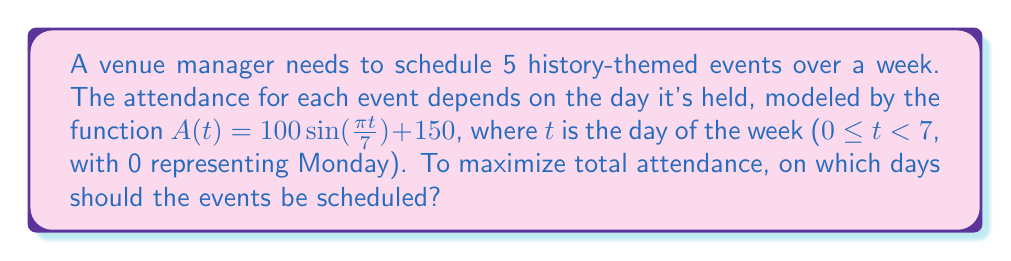What is the answer to this math problem? 1. The attendance function $A(t) = 100 \sin(\frac{\pi t}{7}) + 150$ represents a sinusoidal curve with a period of 7 days.

2. To maximize total attendance, we need to find the 5 highest points on this curve within the domain 0 ≤ t < 7.

3. The maximum of a sine function occurs at $\frac{\pi}{2} + 2\pi n$, where n is an integer. In our case:

   $$\frac{\pi t}{7} = \frac{\pi}{2}$$
   $$t = \frac{7}{2} = 3.5$$

4. This maximum occurs on Thursday afternoon (day 3.5). The next highest points will be equally spaced on either side of this peak.

5. To find these points, we can use the following formula:
   $$t_k = 3.5 + k, \text{ where } k = \{-2, -1, 0, 1, 2\}$$

6. This gives us:
   $t_1 = 1.5$ (Tuesday afternoon)
   $t_2 = 2.5$ (Wednesday afternoon)
   $t_3 = 3.5$ (Thursday afternoon)
   $t_4 = 4.5$ (Friday afternoon)
   $t_5 = 5.5$ (Saturday afternoon)

7. Rounding to the nearest day for practical scheduling:
   Tuesday, Wednesday, Thursday, Friday, and Saturday.
Answer: Tuesday, Wednesday, Thursday, Friday, Saturday 